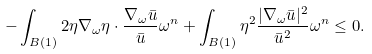<formula> <loc_0><loc_0><loc_500><loc_500>- \int _ { B ( 1 ) } 2 \eta \nabla _ { \omega } \eta \cdot \frac { \nabla _ { \omega } \bar { u } } { \bar { u } } \omega ^ { n } + \int _ { B ( 1 ) } \eta ^ { 2 } \frac { | \nabla _ { \omega } \bar { u } | ^ { 2 } } { \bar { u } ^ { 2 } } \omega ^ { n } \leq 0 .</formula> 